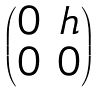<formula> <loc_0><loc_0><loc_500><loc_500>\begin{pmatrix} 0 & h \\ 0 & 0 \end{pmatrix}</formula> 